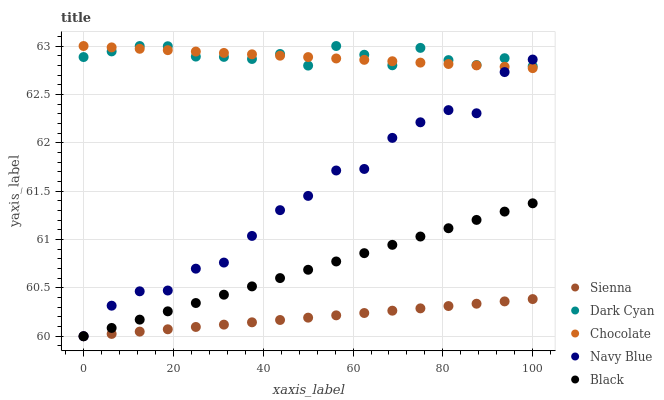Does Sienna have the minimum area under the curve?
Answer yes or no. Yes. Does Dark Cyan have the maximum area under the curve?
Answer yes or no. Yes. Does Navy Blue have the minimum area under the curve?
Answer yes or no. No. Does Navy Blue have the maximum area under the curve?
Answer yes or no. No. Is Sienna the smoothest?
Answer yes or no. Yes. Is Navy Blue the roughest?
Answer yes or no. Yes. Is Dark Cyan the smoothest?
Answer yes or no. No. Is Dark Cyan the roughest?
Answer yes or no. No. Does Sienna have the lowest value?
Answer yes or no. Yes. Does Dark Cyan have the lowest value?
Answer yes or no. No. Does Chocolate have the highest value?
Answer yes or no. Yes. Does Navy Blue have the highest value?
Answer yes or no. No. Is Black less than Chocolate?
Answer yes or no. Yes. Is Dark Cyan greater than Black?
Answer yes or no. Yes. Does Dark Cyan intersect Navy Blue?
Answer yes or no. Yes. Is Dark Cyan less than Navy Blue?
Answer yes or no. No. Is Dark Cyan greater than Navy Blue?
Answer yes or no. No. Does Black intersect Chocolate?
Answer yes or no. No. 